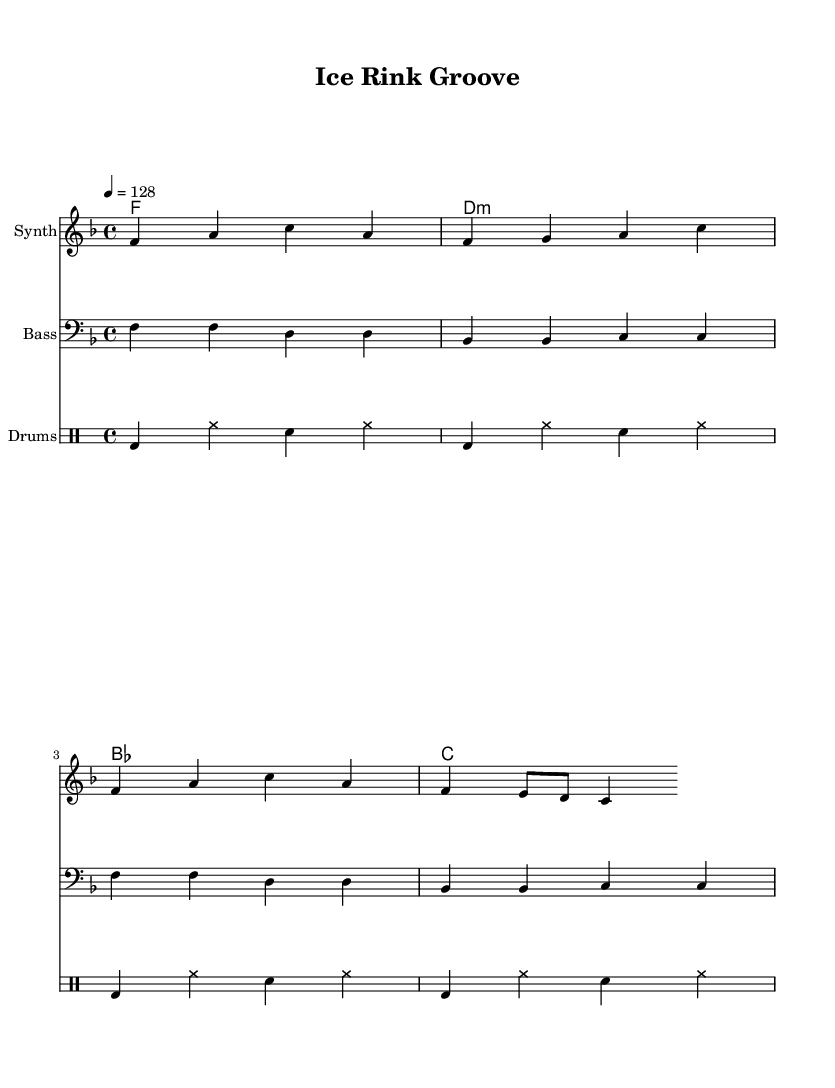What is the key signature of this music? The key signature indicated by the notation shows one flat, which corresponds to F major.
Answer: F major What is the time signature of the piece? The time signature is shown at the beginning of the score and is indicated as 4/4, meaning there are four beats in each measure and a quarter note receives one beat.
Answer: 4/4 What is the tempo marking for this piece? The tempo marking is shown as "4 = 128," which means there are 128 beats per minute, indicating a moderately fast pace typical for dance music.
Answer: 128 How many measures are there in the melody section? By counting the standard bars in the melody, there are a total of four measures represented in the sheet music.
Answer: 4 measures What type of harmony is used in this piece? The harmony line is indicated as a chord mode; the specific chords that are used indicate a mix of major and minor harmonies, typically seen in dance music.
Answer: Major and minor chords What style of drums is indicated in the score? The drum patterns are set in a typical dance music style, evident through the use of bass drum, hi-hat, and snare patterns.
Answer: Dance style What is the instrument used for the melody? The melody is played by a Synth, as indicated at the beginning of the respective staff line in the score.
Answer: Synth 